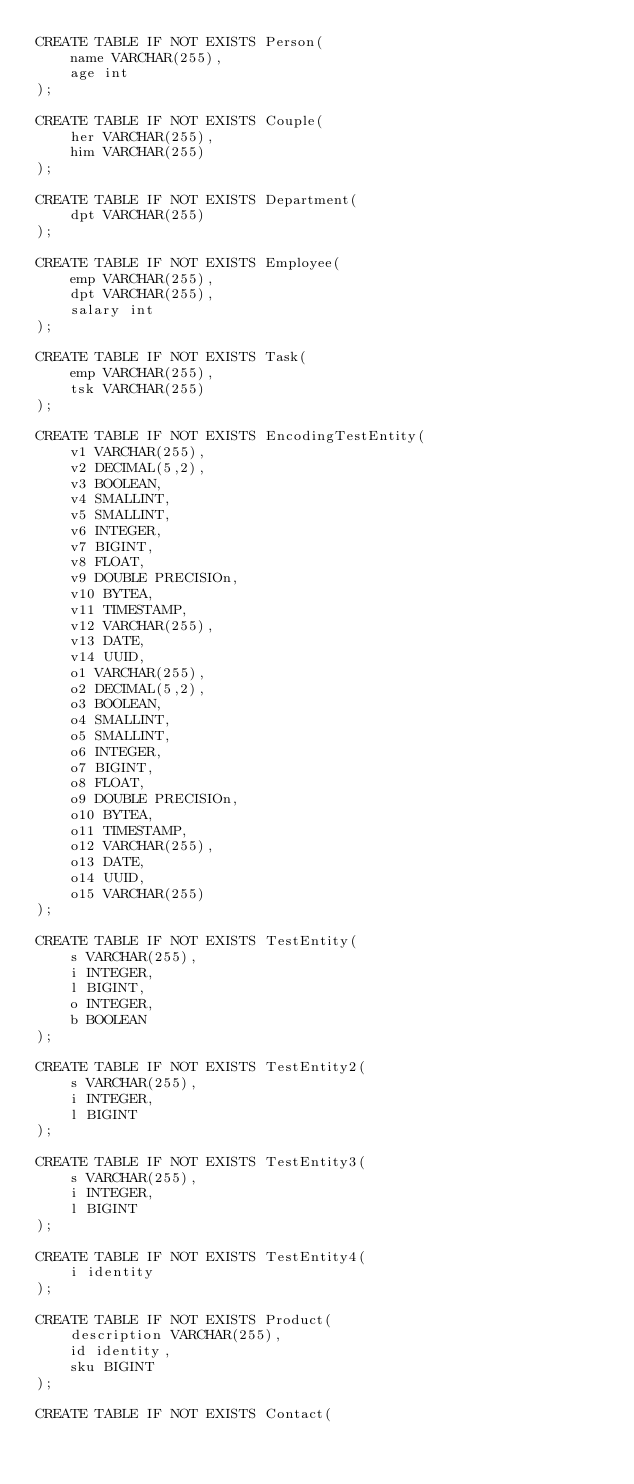<code> <loc_0><loc_0><loc_500><loc_500><_SQL_>CREATE TABLE IF NOT EXISTS Person(
    name VARCHAR(255),
    age int
);

CREATE TABLE IF NOT EXISTS Couple(
    her VARCHAR(255),
    him VARCHAR(255)
);

CREATE TABLE IF NOT EXISTS Department(
    dpt VARCHAR(255)
);

CREATE TABLE IF NOT EXISTS Employee(
    emp VARCHAR(255),
    dpt VARCHAR(255),
    salary int
);

CREATE TABLE IF NOT EXISTS Task(
    emp VARCHAR(255),
    tsk VARCHAR(255)
);

CREATE TABLE IF NOT EXISTS EncodingTestEntity(
    v1 VARCHAR(255),
    v2 DECIMAL(5,2),
    v3 BOOLEAN,
    v4 SMALLINT,
    v5 SMALLINT,
    v6 INTEGER,
    v7 BIGINT,
    v8 FLOAT,
    v9 DOUBLE PRECISIOn,
    v10 BYTEA,
    v11 TIMESTAMP,
    v12 VARCHAR(255),
    v13 DATE,
    v14 UUID,
    o1 VARCHAR(255),
    o2 DECIMAL(5,2),
    o3 BOOLEAN,
    o4 SMALLINT,
    o5 SMALLINT,
    o6 INTEGER,
    o7 BIGINT,
    o8 FLOAT,
    o9 DOUBLE PRECISIOn,
    o10 BYTEA,
    o11 TIMESTAMP,
    o12 VARCHAR(255),
    o13 DATE,
    o14 UUID,
    o15 VARCHAR(255)
);

CREATE TABLE IF NOT EXISTS TestEntity(
    s VARCHAR(255),
    i INTEGER,
    l BIGINT,
    o INTEGER,
    b BOOLEAN
);

CREATE TABLE IF NOT EXISTS TestEntity2(
    s VARCHAR(255),
    i INTEGER,
    l BIGINT
);

CREATE TABLE IF NOT EXISTS TestEntity3(
    s VARCHAR(255),
    i INTEGER,
    l BIGINT
);

CREATE TABLE IF NOT EXISTS TestEntity4(
    i identity
);

CREATE TABLE IF NOT EXISTS Product(
    description VARCHAR(255),
    id identity,
    sku BIGINT
);

CREATE TABLE IF NOT EXISTS Contact(</code> 